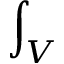<formula> <loc_0><loc_0><loc_500><loc_500>\int _ { V }</formula> 